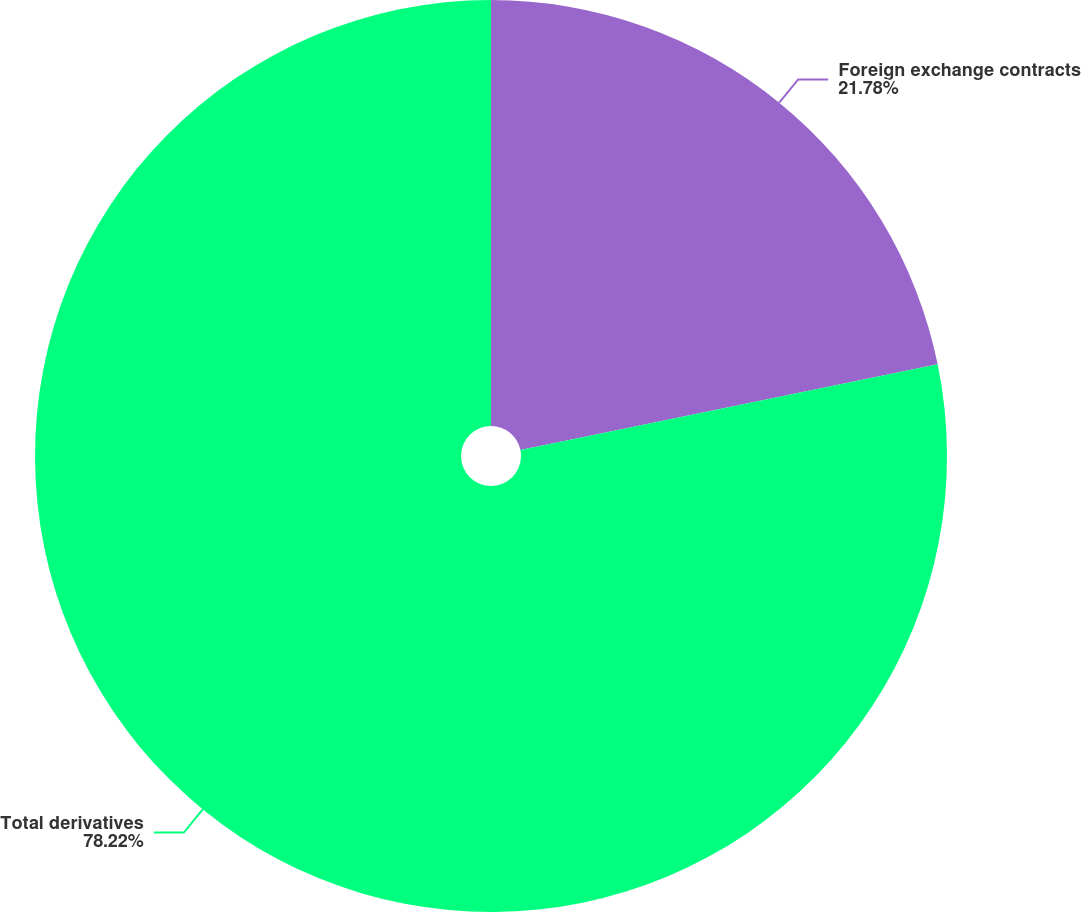Convert chart to OTSL. <chart><loc_0><loc_0><loc_500><loc_500><pie_chart><fcel>Foreign exchange contracts<fcel>Total derivatives<nl><fcel>21.78%<fcel>78.22%<nl></chart> 